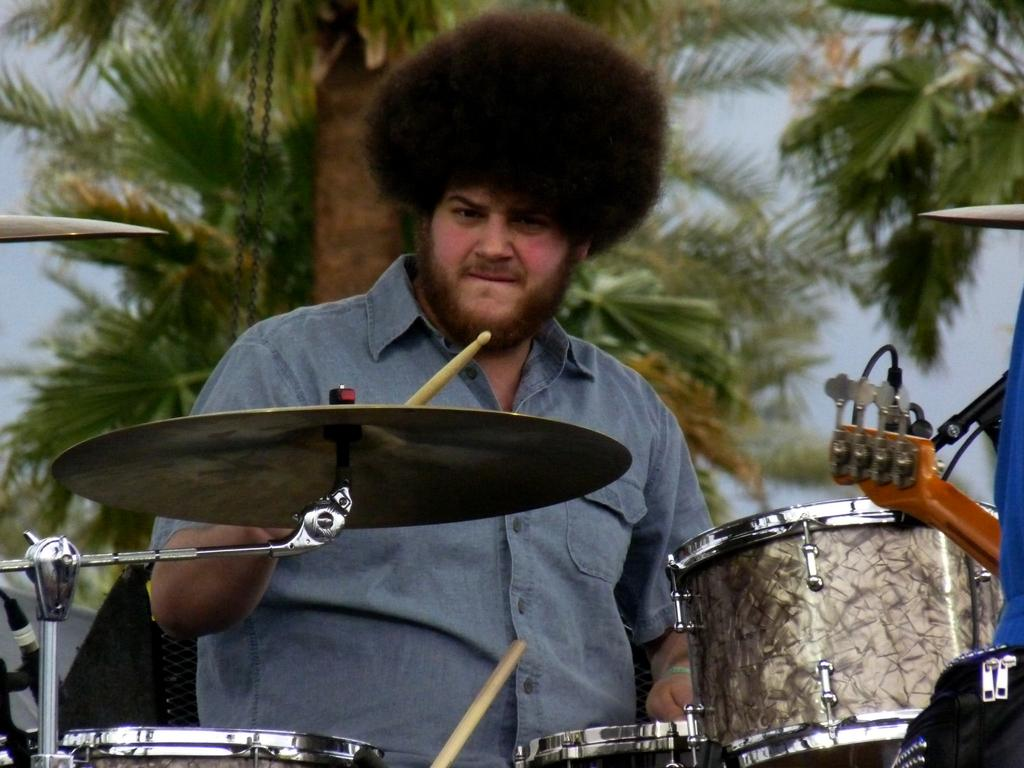What is the person in the image doing? The person is playing drums. What object is located behind the person? There is a speaker behind the person. What type of vegetation can be seen in the image? There is a tree visible in the image. What is visible at the top of the image? The sky is visible at the top of the image. What type of invention is the person using to play the drums in the image? The person is not using any invention to play the drums in the image; they are using traditional drumsticks. What type of badge can be seen on the tree in the image? There is no badge present on the tree in the image. 